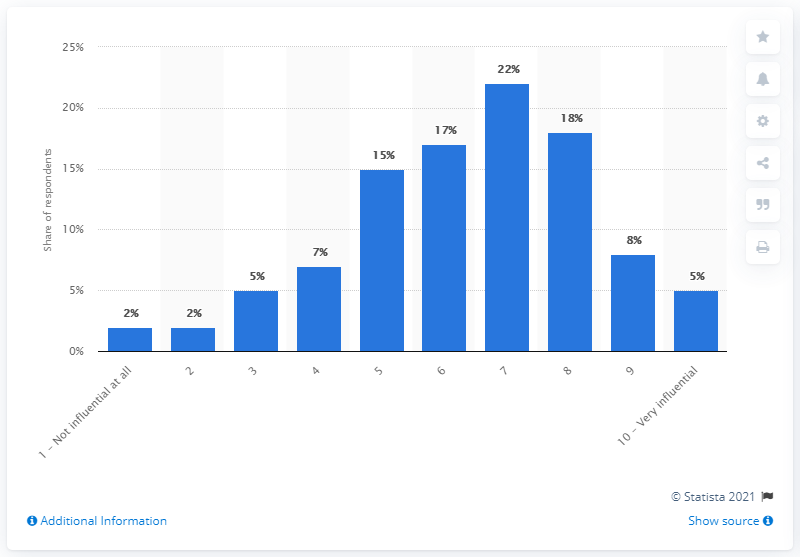Specify some key components in this picture. According to a survey of young people, society has a significant influence on their future happiness, with 5% of respondents stating that they believe society has a strong impact on their happiness. Which point scale has the same number of votes as the others? [1 - Not influential at all, 2]... Of the point scales surveyed, those with a value greater than 16% include 3. 